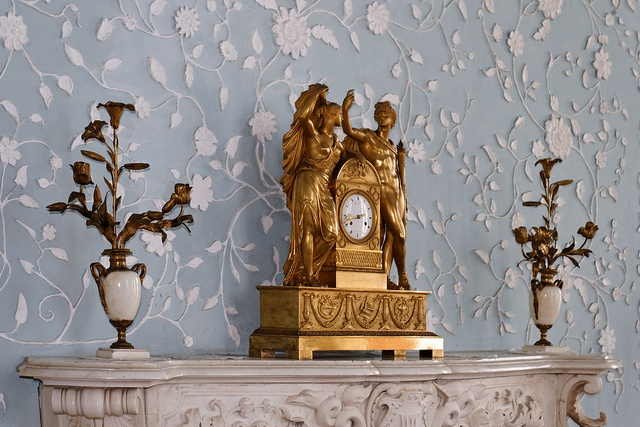Describe the objects in this image and their specific colors. I can see vase in darkgray, black, and maroon tones, vase in darkgray, black, and gray tones, and clock in darkgray, lightgray, and brown tones in this image. 